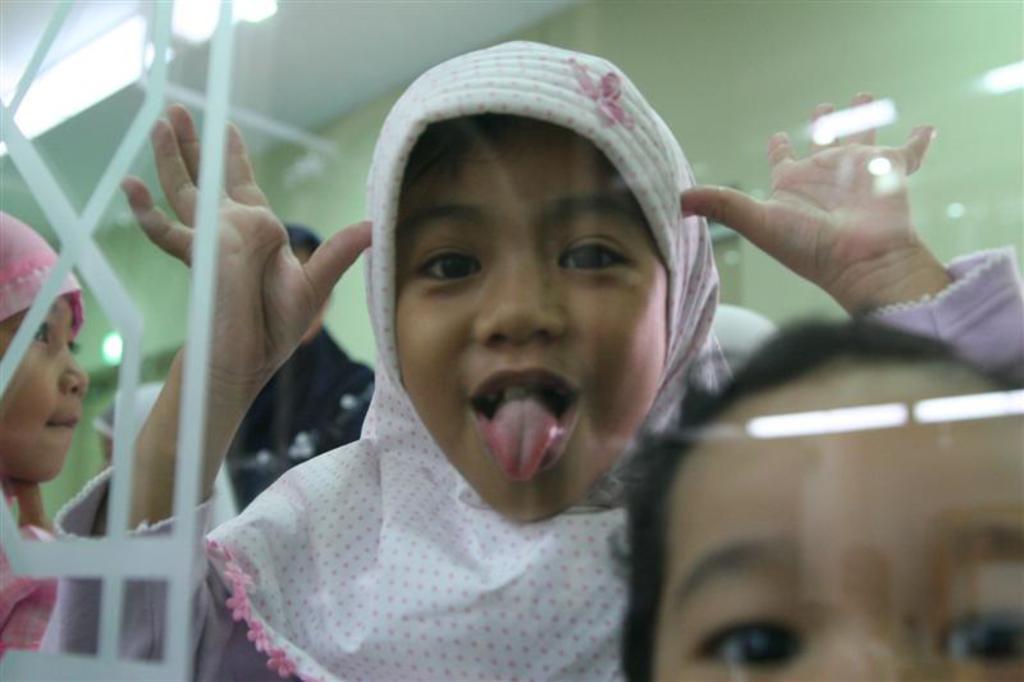Could you give a brief overview of what you see in this image? In the middle a girl is showing her tongue and raising her two hands. She wore a white color hijab. 